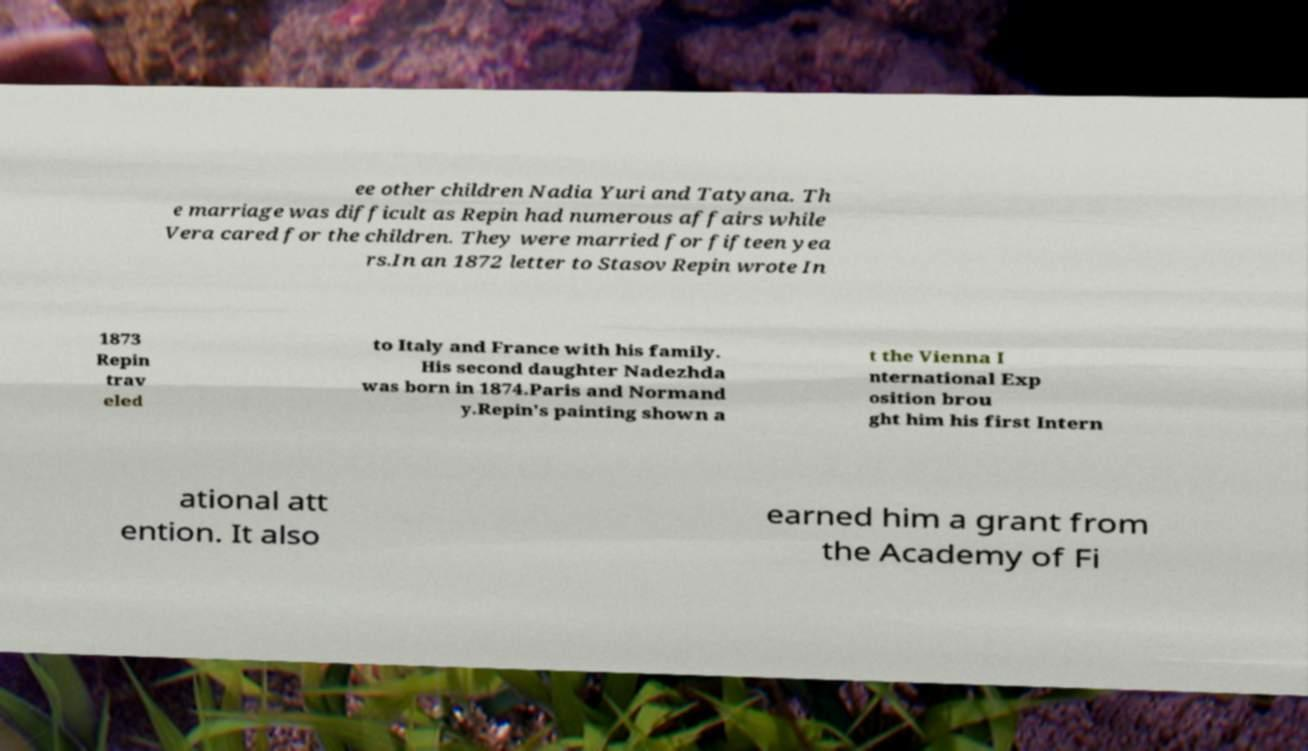I need the written content from this picture converted into text. Can you do that? ee other children Nadia Yuri and Tatyana. Th e marriage was difficult as Repin had numerous affairs while Vera cared for the children. They were married for fifteen yea rs.In an 1872 letter to Stasov Repin wrote In 1873 Repin trav eled to Italy and France with his family. His second daughter Nadezhda was born in 1874.Paris and Normand y.Repin's painting shown a t the Vienna I nternational Exp osition brou ght him his first Intern ational att ention. It also earned him a grant from the Academy of Fi 